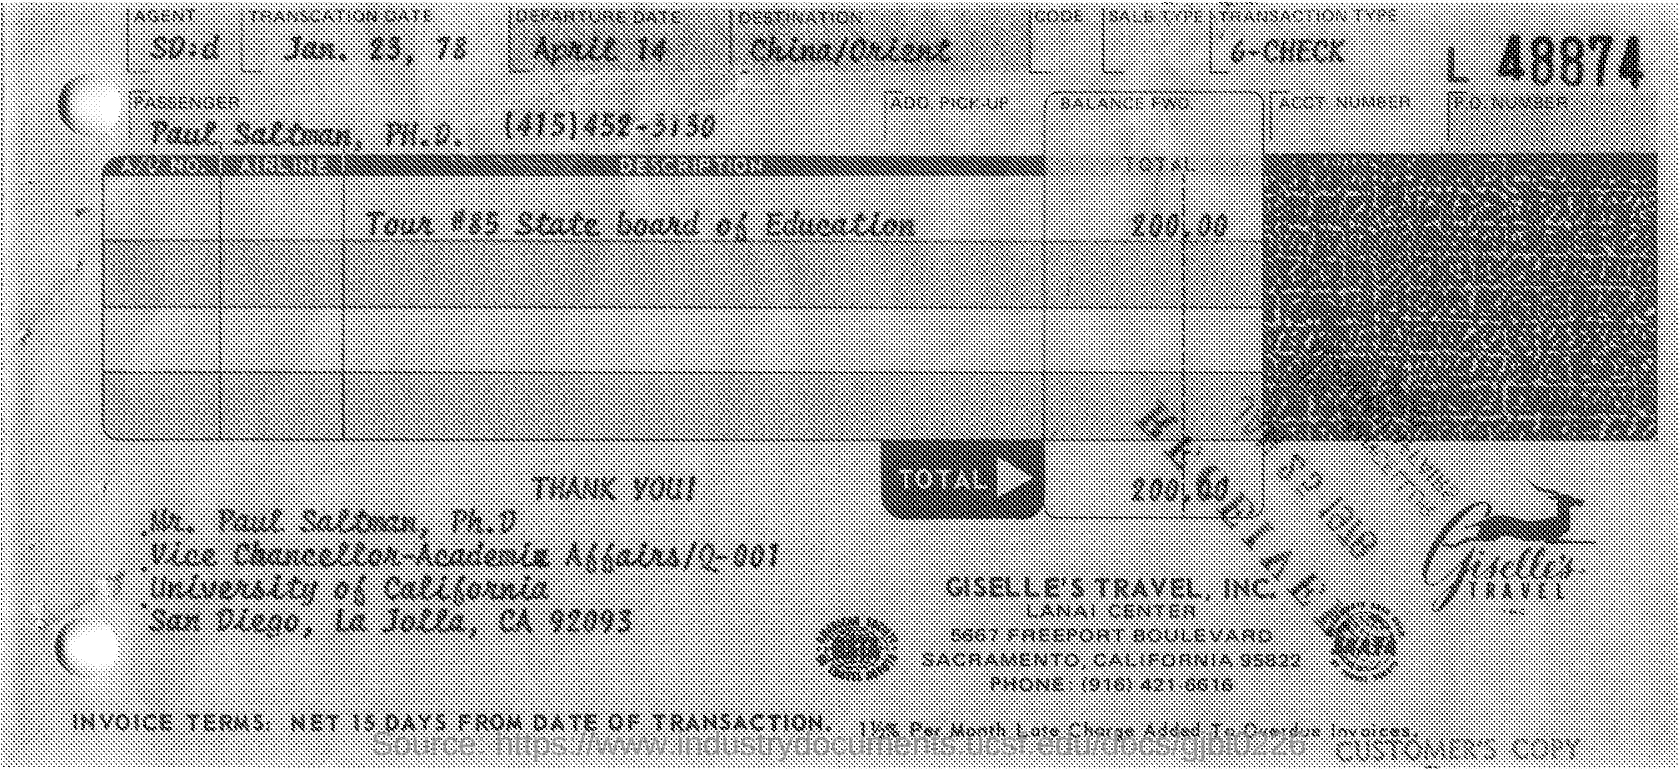Identify some key points in this picture. What is the type of transaction? It is a 6-Check. The location of the DESTINATION is unknown, specifically whether it is in China or the Orient. The transaction was done on January 23, 1978. Giselle's Travel, Inc. is the name of a travel company. The travel expenses are approximately 200.00.. 